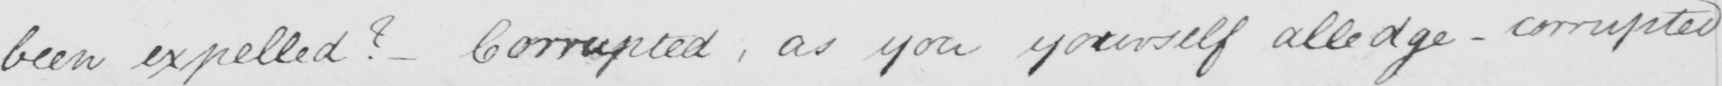What is written in this line of handwriting? been expelled ?   _  Corrupted , as you yourself alledge  _  corrupted 